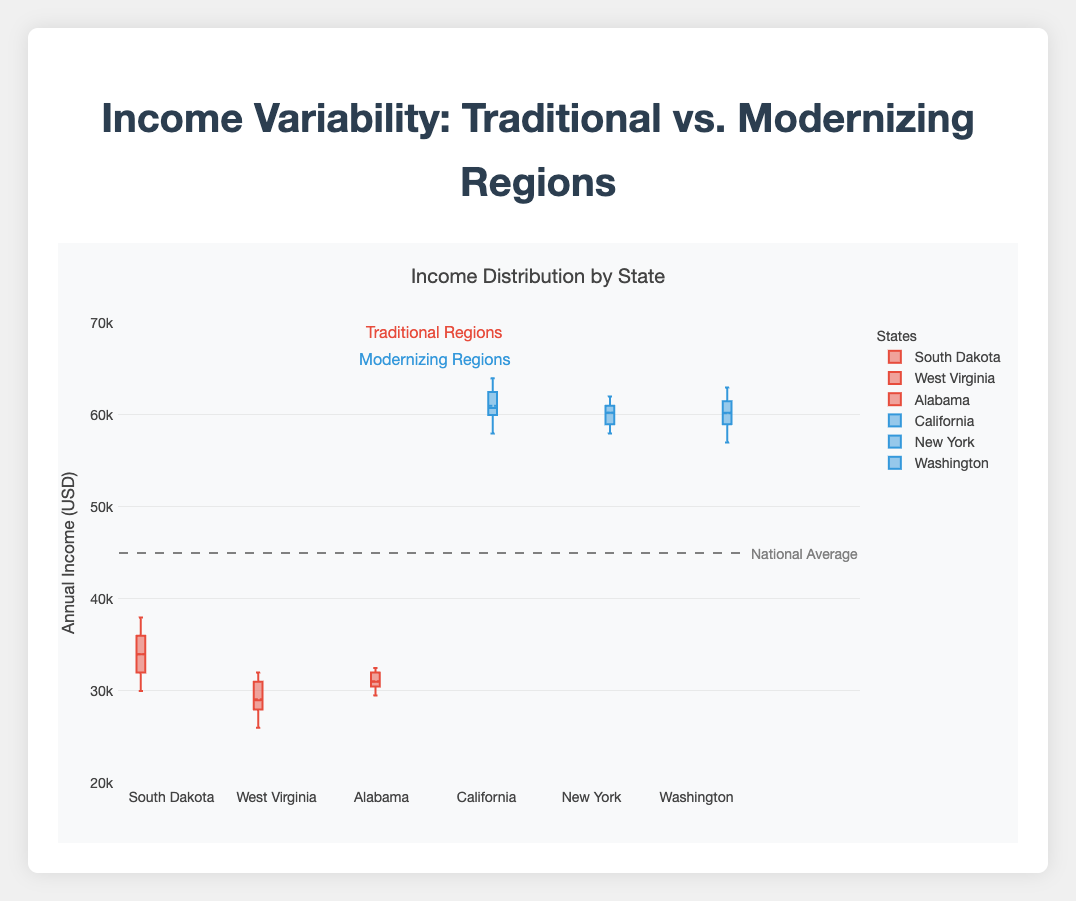What is the title of the plot? The title of the plot is clearly written at the top of the figure. It reads "Income Variability: Traditional vs. Modernizing Regions".
Answer: Income Variability: Traditional vs. Modernizing Regions What is the median income for South Dakota? For South Dakota, you can see the box plot and look at the line inside the box that represents the median value.
Answer: 34000 Which region has the lowest median income? You can determine the lowest median income by comparing the median lines in the boxes for all regions. West Virginia has the lowest median line.
Answer: West Virginia How do the incomes in traditional regions compare to modernizing regions in terms of overall median values? Identify the median values for all traditional and modernizing regions from the box plots. Calculate the average of medians for each category and compare them. Traditional regions have median values around the mid-$30,000s to mid-$20,000s range whereas modernizing regions have median values around the $60,000s range.
Answer: Modernizing regions have higher median incomes than traditional regions What does the dashed line in the plot represent? The annotation in the plot provides an indication that the dashed line marked at an income level of 45000 represents the national average income.
Answer: National average income Which region has the widest range of income variability, and what does that suggest? By looking at the length of the boxes (interquartile range) and the whiskers (total range) in the box plots, we can see that South Dakota has the widest range. This suggests a higher income disparity in South Dakota compared to other regions.
Answer: South Dakota What is the highest income observed in the traditional regions? Examine the highest points (top of the whiskers) in the box plots for all traditional regions. The highest value is in South Dakota at 38000.
Answer: 38000 Which modernizing region has the highest median income? The median income for each modernizing region is shown by the line inside each box. California has the highest median income among the modernizing regions.
Answer: California Is there any overlap between the income ranges of traditional and modernizing regions? Compare the whisker ranges of the traditional and modernizing regions. The highest incomes in traditional regions overlap with the lower range of incomes in modernizing regions, suggesting some overlap.
Answer: Yes 